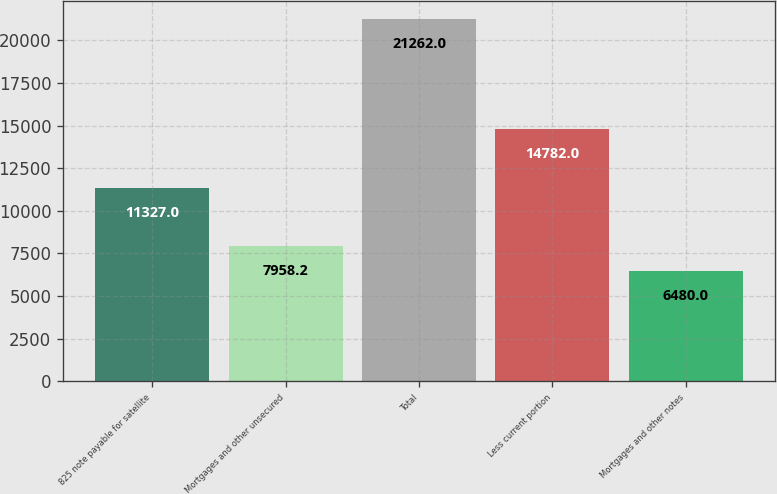Convert chart. <chart><loc_0><loc_0><loc_500><loc_500><bar_chart><fcel>825 note payable for satellite<fcel>Mortgages and other unsecured<fcel>Total<fcel>Less current portion<fcel>Mortgages and other notes<nl><fcel>11327<fcel>7958.2<fcel>21262<fcel>14782<fcel>6480<nl></chart> 